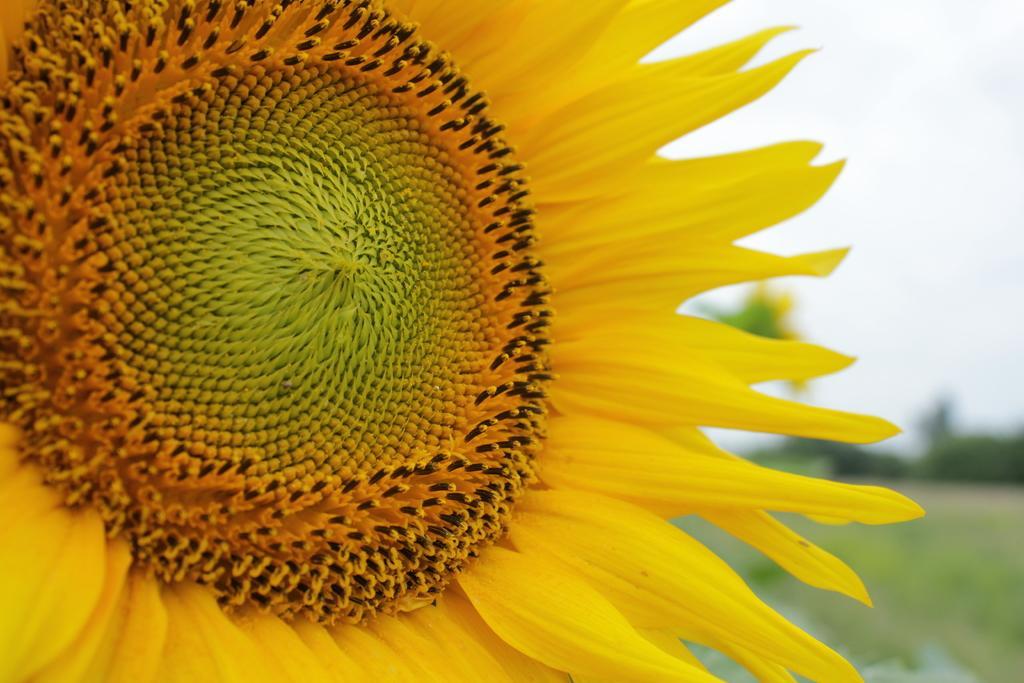Please provide a concise description of this image. In the image we can see a flower. Background of the image is blur. In the top right corner of the image we can see the sky. 